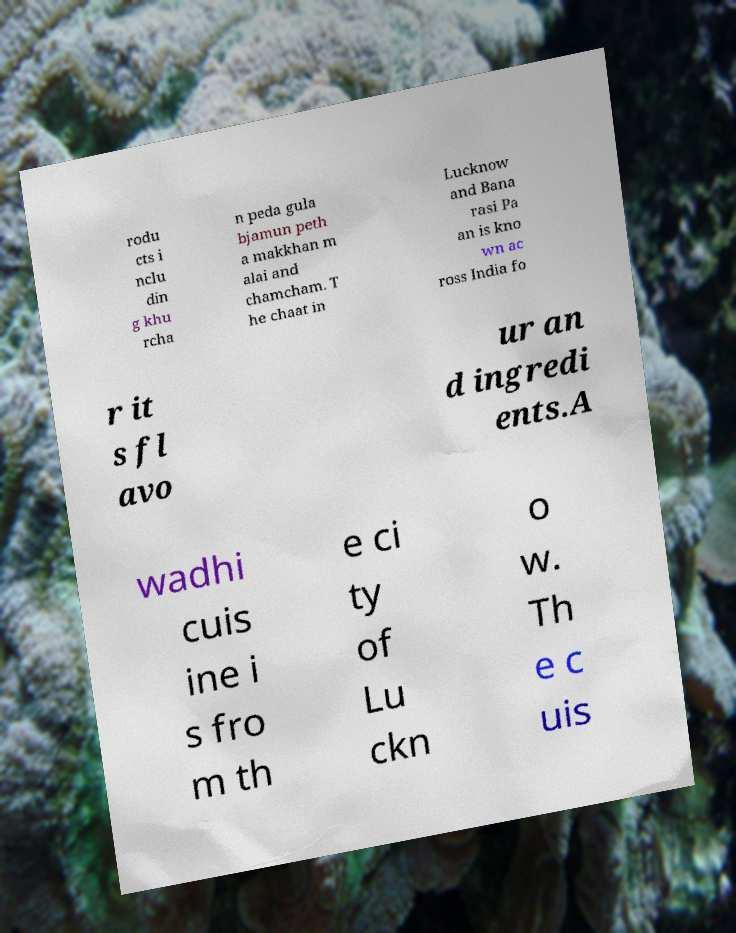Could you assist in decoding the text presented in this image and type it out clearly? rodu cts i nclu din g khu rcha n peda gula bjamun peth a makkhan m alai and chamcham. T he chaat in Lucknow and Bana rasi Pa an is kno wn ac ross India fo r it s fl avo ur an d ingredi ents.A wadhi cuis ine i s fro m th e ci ty of Lu ckn o w. Th e c uis 